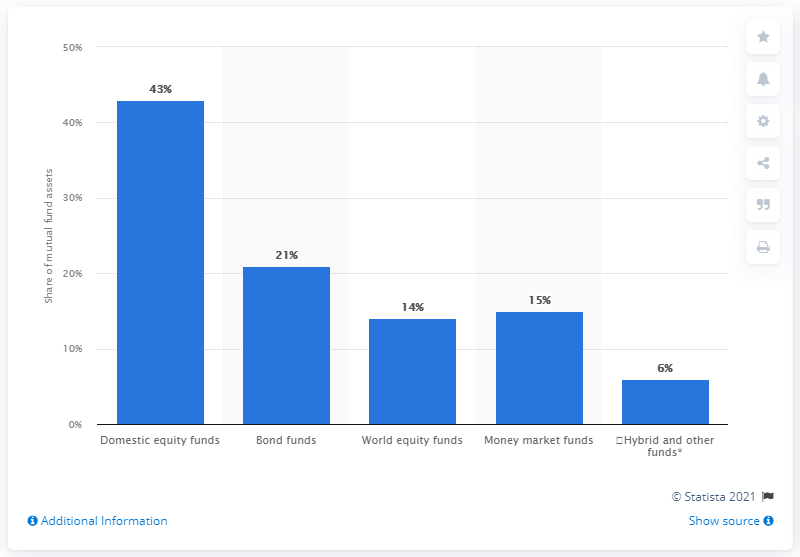Give some essential details in this illustration. In 2020, approximately 43% of the mutual fund and ETF assets in the United States were invested in domestic equity funds. 